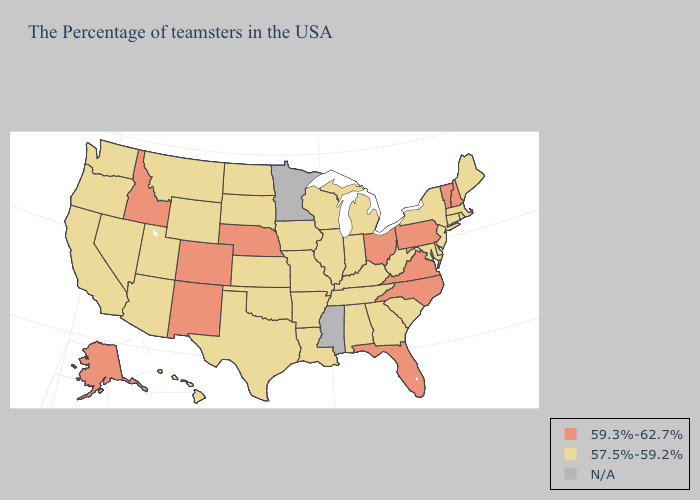Which states have the highest value in the USA?
Write a very short answer. New Hampshire, Vermont, Pennsylvania, Virginia, North Carolina, Ohio, Florida, Nebraska, Colorado, New Mexico, Idaho, Alaska. What is the lowest value in states that border Nebraska?
Short answer required. 57.5%-59.2%. Which states have the lowest value in the USA?
Give a very brief answer. Maine, Massachusetts, Rhode Island, Connecticut, New York, New Jersey, Delaware, Maryland, South Carolina, West Virginia, Georgia, Michigan, Kentucky, Indiana, Alabama, Tennessee, Wisconsin, Illinois, Louisiana, Missouri, Arkansas, Iowa, Kansas, Oklahoma, Texas, South Dakota, North Dakota, Wyoming, Utah, Montana, Arizona, Nevada, California, Washington, Oregon, Hawaii. Does Oklahoma have the highest value in the South?
Short answer required. No. Name the states that have a value in the range 59.3%-62.7%?
Write a very short answer. New Hampshire, Vermont, Pennsylvania, Virginia, North Carolina, Ohio, Florida, Nebraska, Colorado, New Mexico, Idaho, Alaska. Name the states that have a value in the range 57.5%-59.2%?
Answer briefly. Maine, Massachusetts, Rhode Island, Connecticut, New York, New Jersey, Delaware, Maryland, South Carolina, West Virginia, Georgia, Michigan, Kentucky, Indiana, Alabama, Tennessee, Wisconsin, Illinois, Louisiana, Missouri, Arkansas, Iowa, Kansas, Oklahoma, Texas, South Dakota, North Dakota, Wyoming, Utah, Montana, Arizona, Nevada, California, Washington, Oregon, Hawaii. What is the value of Montana?
Give a very brief answer. 57.5%-59.2%. Is the legend a continuous bar?
Give a very brief answer. No. Name the states that have a value in the range 57.5%-59.2%?
Short answer required. Maine, Massachusetts, Rhode Island, Connecticut, New York, New Jersey, Delaware, Maryland, South Carolina, West Virginia, Georgia, Michigan, Kentucky, Indiana, Alabama, Tennessee, Wisconsin, Illinois, Louisiana, Missouri, Arkansas, Iowa, Kansas, Oklahoma, Texas, South Dakota, North Dakota, Wyoming, Utah, Montana, Arizona, Nevada, California, Washington, Oregon, Hawaii. What is the value of Connecticut?
Give a very brief answer. 57.5%-59.2%. Does the map have missing data?
Write a very short answer. Yes. Does Wisconsin have the highest value in the MidWest?
Answer briefly. No. Name the states that have a value in the range N/A?
Keep it brief. Mississippi, Minnesota. Does Alabama have the lowest value in the South?
Short answer required. Yes. 